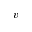Convert formula to latex. <formula><loc_0><loc_0><loc_500><loc_500>v</formula> 